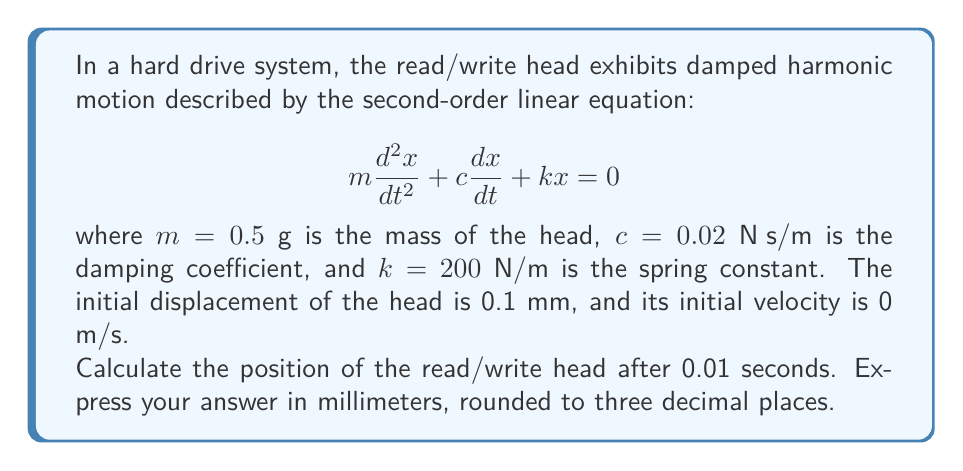Show me your answer to this math problem. To solve this problem, we'll follow these steps:

1) First, we need to determine the characteristic equation of the system:
   $$mr^2 + cr + k = 0$$

2) Substitute the given values:
   $$0.0005r^2 + 0.02r + 200 = 0$$

3) Solve for r using the quadratic formula:
   $$r = \frac{-b \pm \sqrt{b^2 - 4ac}}{2a}$$
   $$r = \frac{-0.02 \pm \sqrt{0.02^2 - 4(0.0005)(200)}}{2(0.0005)}$$
   $$r = -20 \pm 632.45i$$

4) The general solution for this system is:
   $$x(t) = e^{-20t}(A\cos(632.45t) + B\sin(632.45t))$$

5) To find A and B, we use the initial conditions:
   At $t=0$, $x(0) = 0.1$ mm $= 0.0001$ m
   At $t=0$, $x'(0) = 0$ m/s

6) From $x(0) = 0.0001$, we get:
   $$A = 0.0001$$

7) From $x'(0) = 0$, we get:
   $$-20A + 632.45B = 0$$
   $$B = \frac{20A}{632.45} = 0.00000316$$

8) Our solution is:
   $$x(t) = e^{-20t}(0.0001\cos(632.45t) + 0.00000316\sin(632.45t))$$

9) Evaluate at $t = 0.01$ seconds:
   $$x(0.01) = e^{-20(0.01)}(0.0001\cos(632.45(0.01)) + 0.00000316\sin(632.45(0.01)))$$
   $$x(0.01) = 0.8187(0.0001(-0.8480) + 0.00000316(0.5300))$$
   $$x(0.01) = -0.0000694 \text{ m} = -0.0694 \text{ mm}$$
Answer: -0.069 mm 